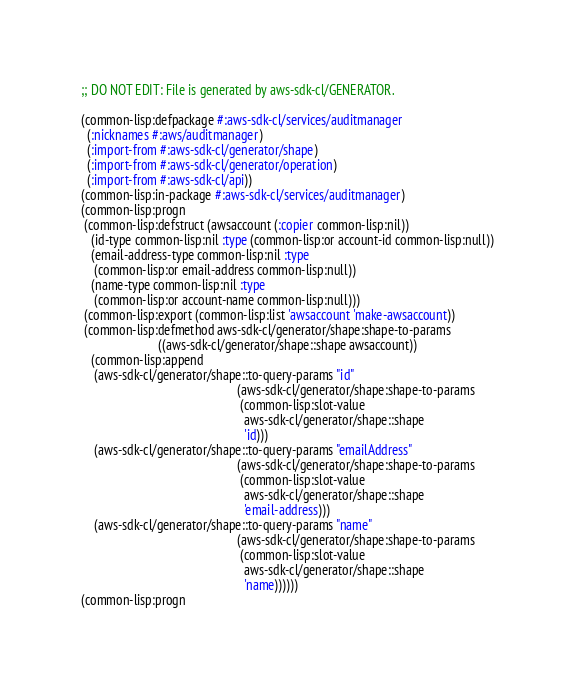<code> <loc_0><loc_0><loc_500><loc_500><_Lisp_>;; DO NOT EDIT: File is generated by aws-sdk-cl/GENERATOR.

(common-lisp:defpackage #:aws-sdk-cl/services/auditmanager
  (:nicknames #:aws/auditmanager)
  (:import-from #:aws-sdk-cl/generator/shape)
  (:import-from #:aws-sdk-cl/generator/operation)
  (:import-from #:aws-sdk-cl/api))
(common-lisp:in-package #:aws-sdk-cl/services/auditmanager)
(common-lisp:progn
 (common-lisp:defstruct (awsaccount (:copier common-lisp:nil))
   (id-type common-lisp:nil :type (common-lisp:or account-id common-lisp:null))
   (email-address-type common-lisp:nil :type
    (common-lisp:or email-address common-lisp:null))
   (name-type common-lisp:nil :type
    (common-lisp:or account-name common-lisp:null)))
 (common-lisp:export (common-lisp:list 'awsaccount 'make-awsaccount))
 (common-lisp:defmethod aws-sdk-cl/generator/shape:shape-to-params
                        ((aws-sdk-cl/generator/shape::shape awsaccount))
   (common-lisp:append
    (aws-sdk-cl/generator/shape::to-query-params "id"
                                                 (aws-sdk-cl/generator/shape:shape-to-params
                                                  (common-lisp:slot-value
                                                   aws-sdk-cl/generator/shape::shape
                                                   'id)))
    (aws-sdk-cl/generator/shape::to-query-params "emailAddress"
                                                 (aws-sdk-cl/generator/shape:shape-to-params
                                                  (common-lisp:slot-value
                                                   aws-sdk-cl/generator/shape::shape
                                                   'email-address)))
    (aws-sdk-cl/generator/shape::to-query-params "name"
                                                 (aws-sdk-cl/generator/shape:shape-to-params
                                                  (common-lisp:slot-value
                                                   aws-sdk-cl/generator/shape::shape
                                                   'name))))))
(common-lisp:progn</code> 